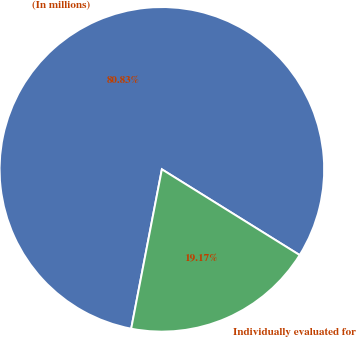<chart> <loc_0><loc_0><loc_500><loc_500><pie_chart><fcel>(In millions)<fcel>Individually evaluated for<nl><fcel>80.83%<fcel>19.17%<nl></chart> 